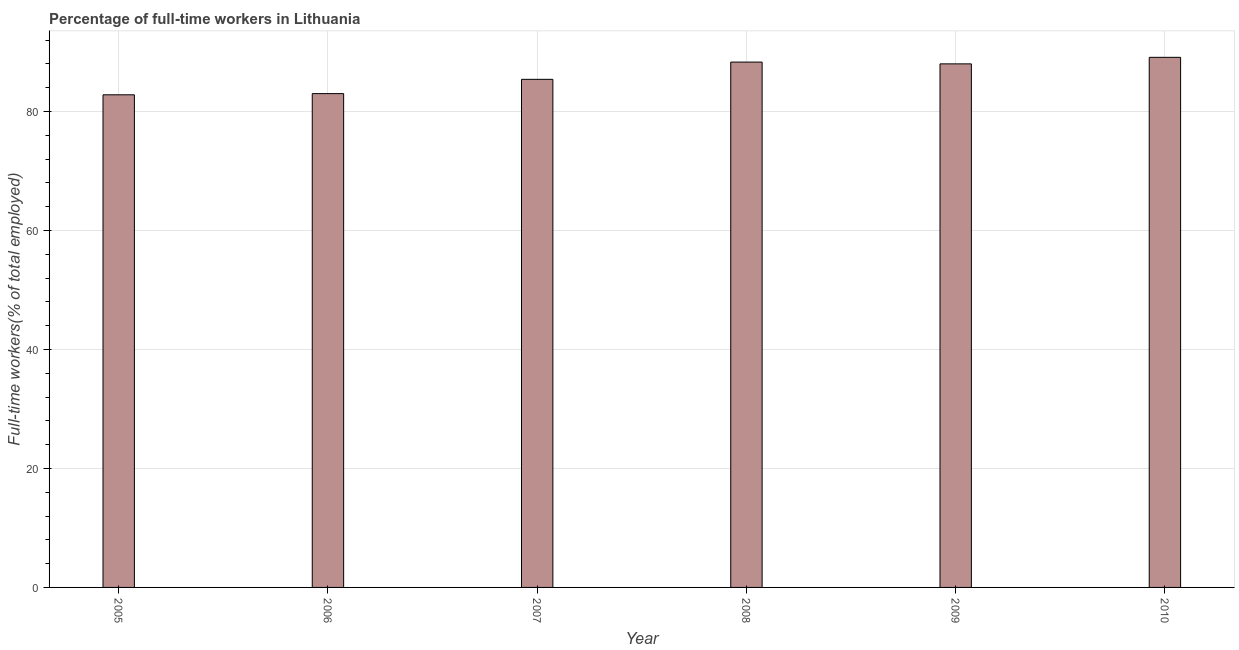Does the graph contain grids?
Your answer should be very brief. Yes. What is the title of the graph?
Give a very brief answer. Percentage of full-time workers in Lithuania. What is the label or title of the X-axis?
Offer a very short reply. Year. What is the label or title of the Y-axis?
Ensure brevity in your answer.  Full-time workers(% of total employed). What is the percentage of full-time workers in 2008?
Offer a very short reply. 88.3. Across all years, what is the maximum percentage of full-time workers?
Provide a short and direct response. 89.1. Across all years, what is the minimum percentage of full-time workers?
Offer a terse response. 82.8. In which year was the percentage of full-time workers minimum?
Offer a very short reply. 2005. What is the sum of the percentage of full-time workers?
Keep it short and to the point. 516.6. What is the average percentage of full-time workers per year?
Offer a terse response. 86.1. What is the median percentage of full-time workers?
Offer a very short reply. 86.7. In how many years, is the percentage of full-time workers greater than 32 %?
Provide a short and direct response. 6. Do a majority of the years between 2008 and 2005 (inclusive) have percentage of full-time workers greater than 56 %?
Provide a short and direct response. Yes. What is the ratio of the percentage of full-time workers in 2006 to that in 2010?
Your response must be concise. 0.93. Is the percentage of full-time workers in 2007 less than that in 2010?
Ensure brevity in your answer.  Yes. Is the difference between the percentage of full-time workers in 2005 and 2007 greater than the difference between any two years?
Provide a succinct answer. No. What is the difference between the highest and the second highest percentage of full-time workers?
Ensure brevity in your answer.  0.8. Is the sum of the percentage of full-time workers in 2009 and 2010 greater than the maximum percentage of full-time workers across all years?
Offer a terse response. Yes. What is the difference between the highest and the lowest percentage of full-time workers?
Your answer should be very brief. 6.3. In how many years, is the percentage of full-time workers greater than the average percentage of full-time workers taken over all years?
Your response must be concise. 3. Are all the bars in the graph horizontal?
Your response must be concise. No. What is the Full-time workers(% of total employed) of 2005?
Ensure brevity in your answer.  82.8. What is the Full-time workers(% of total employed) of 2006?
Offer a very short reply. 83. What is the Full-time workers(% of total employed) of 2007?
Your answer should be very brief. 85.4. What is the Full-time workers(% of total employed) in 2008?
Provide a succinct answer. 88.3. What is the Full-time workers(% of total employed) of 2009?
Your response must be concise. 88. What is the Full-time workers(% of total employed) of 2010?
Make the answer very short. 89.1. What is the difference between the Full-time workers(% of total employed) in 2005 and 2006?
Your answer should be compact. -0.2. What is the difference between the Full-time workers(% of total employed) in 2005 and 2008?
Keep it short and to the point. -5.5. What is the difference between the Full-time workers(% of total employed) in 2005 and 2010?
Offer a very short reply. -6.3. What is the difference between the Full-time workers(% of total employed) in 2006 and 2010?
Give a very brief answer. -6.1. What is the difference between the Full-time workers(% of total employed) in 2007 and 2008?
Provide a succinct answer. -2.9. What is the difference between the Full-time workers(% of total employed) in 2007 and 2010?
Offer a very short reply. -3.7. What is the difference between the Full-time workers(% of total employed) in 2008 and 2010?
Make the answer very short. -0.8. What is the difference between the Full-time workers(% of total employed) in 2009 and 2010?
Offer a terse response. -1.1. What is the ratio of the Full-time workers(% of total employed) in 2005 to that in 2006?
Offer a very short reply. 1. What is the ratio of the Full-time workers(% of total employed) in 2005 to that in 2007?
Give a very brief answer. 0.97. What is the ratio of the Full-time workers(% of total employed) in 2005 to that in 2008?
Offer a terse response. 0.94. What is the ratio of the Full-time workers(% of total employed) in 2005 to that in 2009?
Offer a very short reply. 0.94. What is the ratio of the Full-time workers(% of total employed) in 2005 to that in 2010?
Provide a succinct answer. 0.93. What is the ratio of the Full-time workers(% of total employed) in 2006 to that in 2007?
Make the answer very short. 0.97. What is the ratio of the Full-time workers(% of total employed) in 2006 to that in 2008?
Keep it short and to the point. 0.94. What is the ratio of the Full-time workers(% of total employed) in 2006 to that in 2009?
Provide a short and direct response. 0.94. What is the ratio of the Full-time workers(% of total employed) in 2006 to that in 2010?
Make the answer very short. 0.93. What is the ratio of the Full-time workers(% of total employed) in 2007 to that in 2008?
Your answer should be compact. 0.97. What is the ratio of the Full-time workers(% of total employed) in 2007 to that in 2009?
Keep it short and to the point. 0.97. What is the ratio of the Full-time workers(% of total employed) in 2007 to that in 2010?
Your answer should be very brief. 0.96. What is the ratio of the Full-time workers(% of total employed) in 2008 to that in 2009?
Offer a very short reply. 1. What is the ratio of the Full-time workers(% of total employed) in 2008 to that in 2010?
Offer a very short reply. 0.99. 